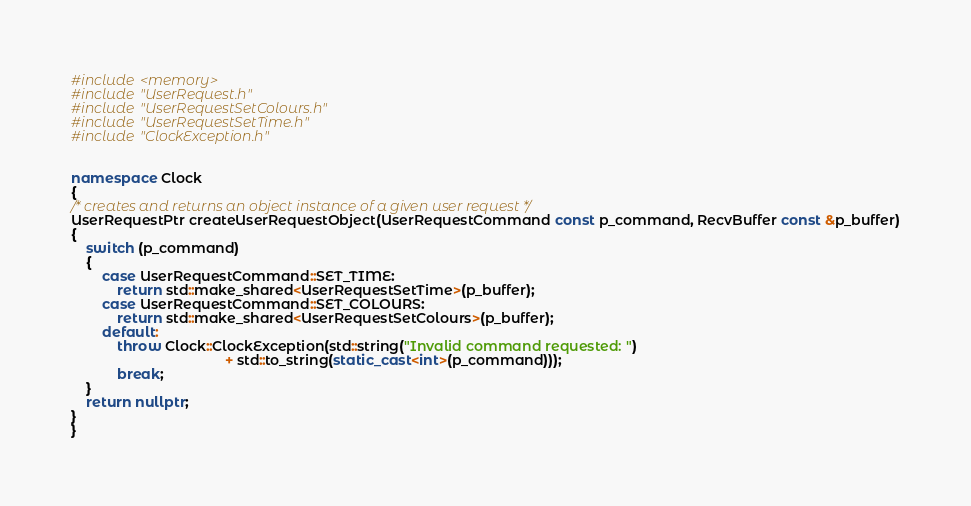Convert code to text. <code><loc_0><loc_0><loc_500><loc_500><_C++_>#include <memory>
#include "UserRequest.h"
#include "UserRequestSetColours.h"
#include "UserRequestSetTime.h"
#include "ClockException.h"


namespace Clock
{
/* creates and returns an object instance of a given user request */
UserRequestPtr createUserRequestObject(UserRequestCommand const p_command, RecvBuffer const &p_buffer)
{
    switch (p_command)
    {
        case UserRequestCommand::SET_TIME:
            return std::make_shared<UserRequestSetTime>(p_buffer);
        case UserRequestCommand::SET_COLOURS:
            return std::make_shared<UserRequestSetColours>(p_buffer);
        default:
            throw Clock::ClockException(std::string("Invalid command requested: ")
                                        + std::to_string(static_cast<int>(p_command)));
            break;
    }
    return nullptr;
}
}
</code> 